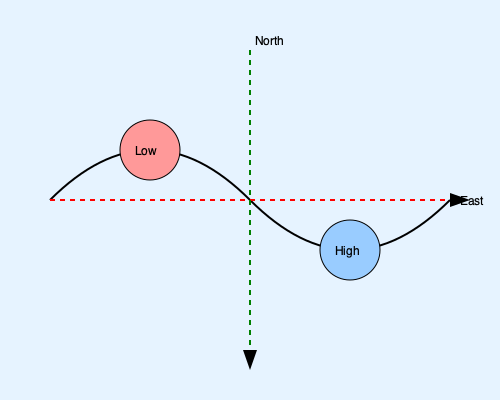Given the weather chart showing a low-pressure system to the northwest and a high-pressure system to the southeast, what is the most efficient sailing route from west to east, and why? To determine the most efficient sailing route, we need to consider the wind patterns around the pressure systems:

1. Wind circulation:
   - Around a low-pressure system in the Northern Hemisphere, winds circulate counterclockwise.
   - Around a high-pressure system in the Northern Hemisphere, winds circulate clockwise.

2. Analyzing the chart:
   - The low-pressure system is to the northwest.
   - The high-pressure system is to the southeast.

3. Wind direction:
   - Between these systems, the winds will generally flow from southwest to northeast.

4. Sailing strategy:
   - Sailboats can typically sail faster at angles to the wind rather than directly downwind.
   - The most efficient point of sail is often a broad reach, where the wind is coming from behind the boat at an angle.

5. Optimal route:
   - Given the wind direction, the most efficient route would be to sail slightly north of the direct east line.
   - This allows the boat to maintain a broad reach, utilizing the southwesterly winds effectively.

6. Additional considerations:
   - The curved line represents the optimal route, taking advantage of the wind patterns.
   - This route also helps avoid the center of the low-pressure system, where winds may be more volatile.

By following this slightly curved northern route, the sailor can maintain an efficient point of sail, utilizing the favorable winds created by the pressure systems to maximize speed and efficiency on the journey from west to east.
Answer: A curved route slightly north of the direct east line, utilizing a broad reach with southwesterly winds. 